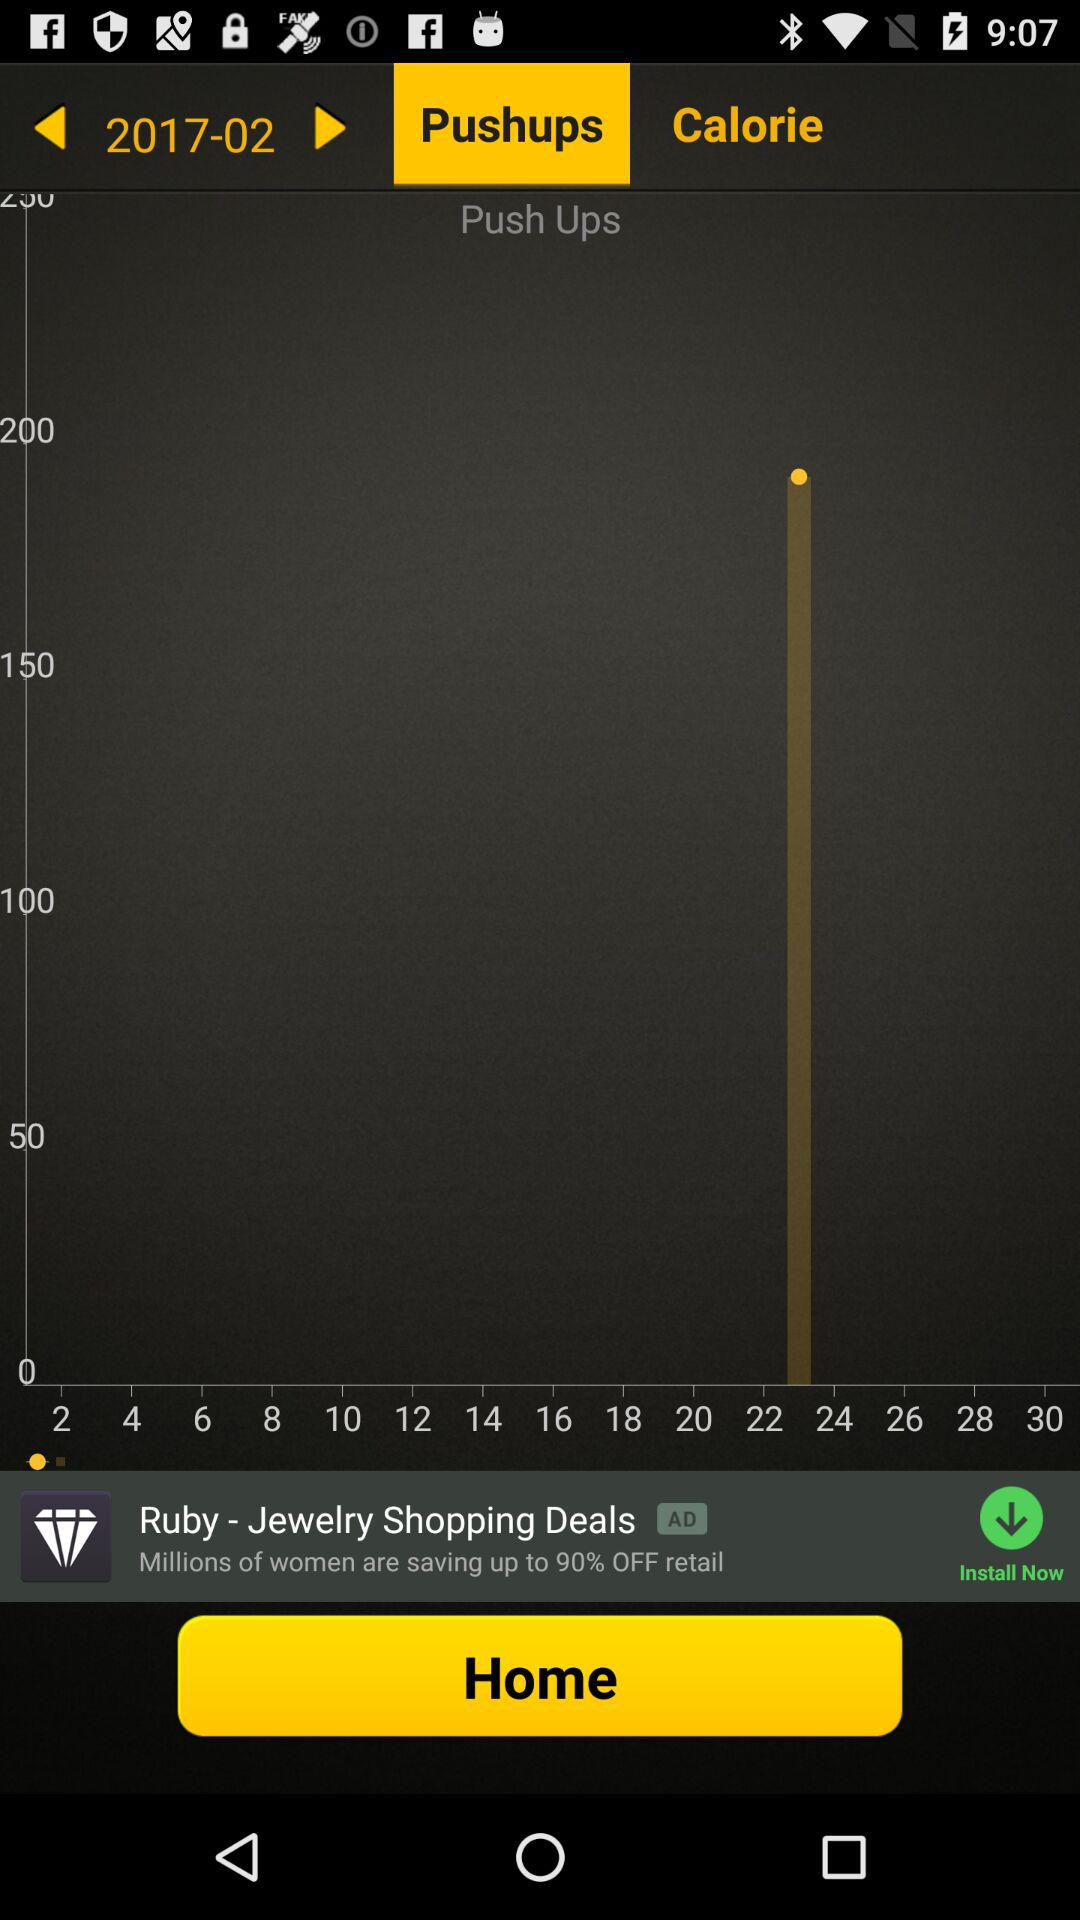What is the selected month and year? The selected month is March and the selected year is 2017. 